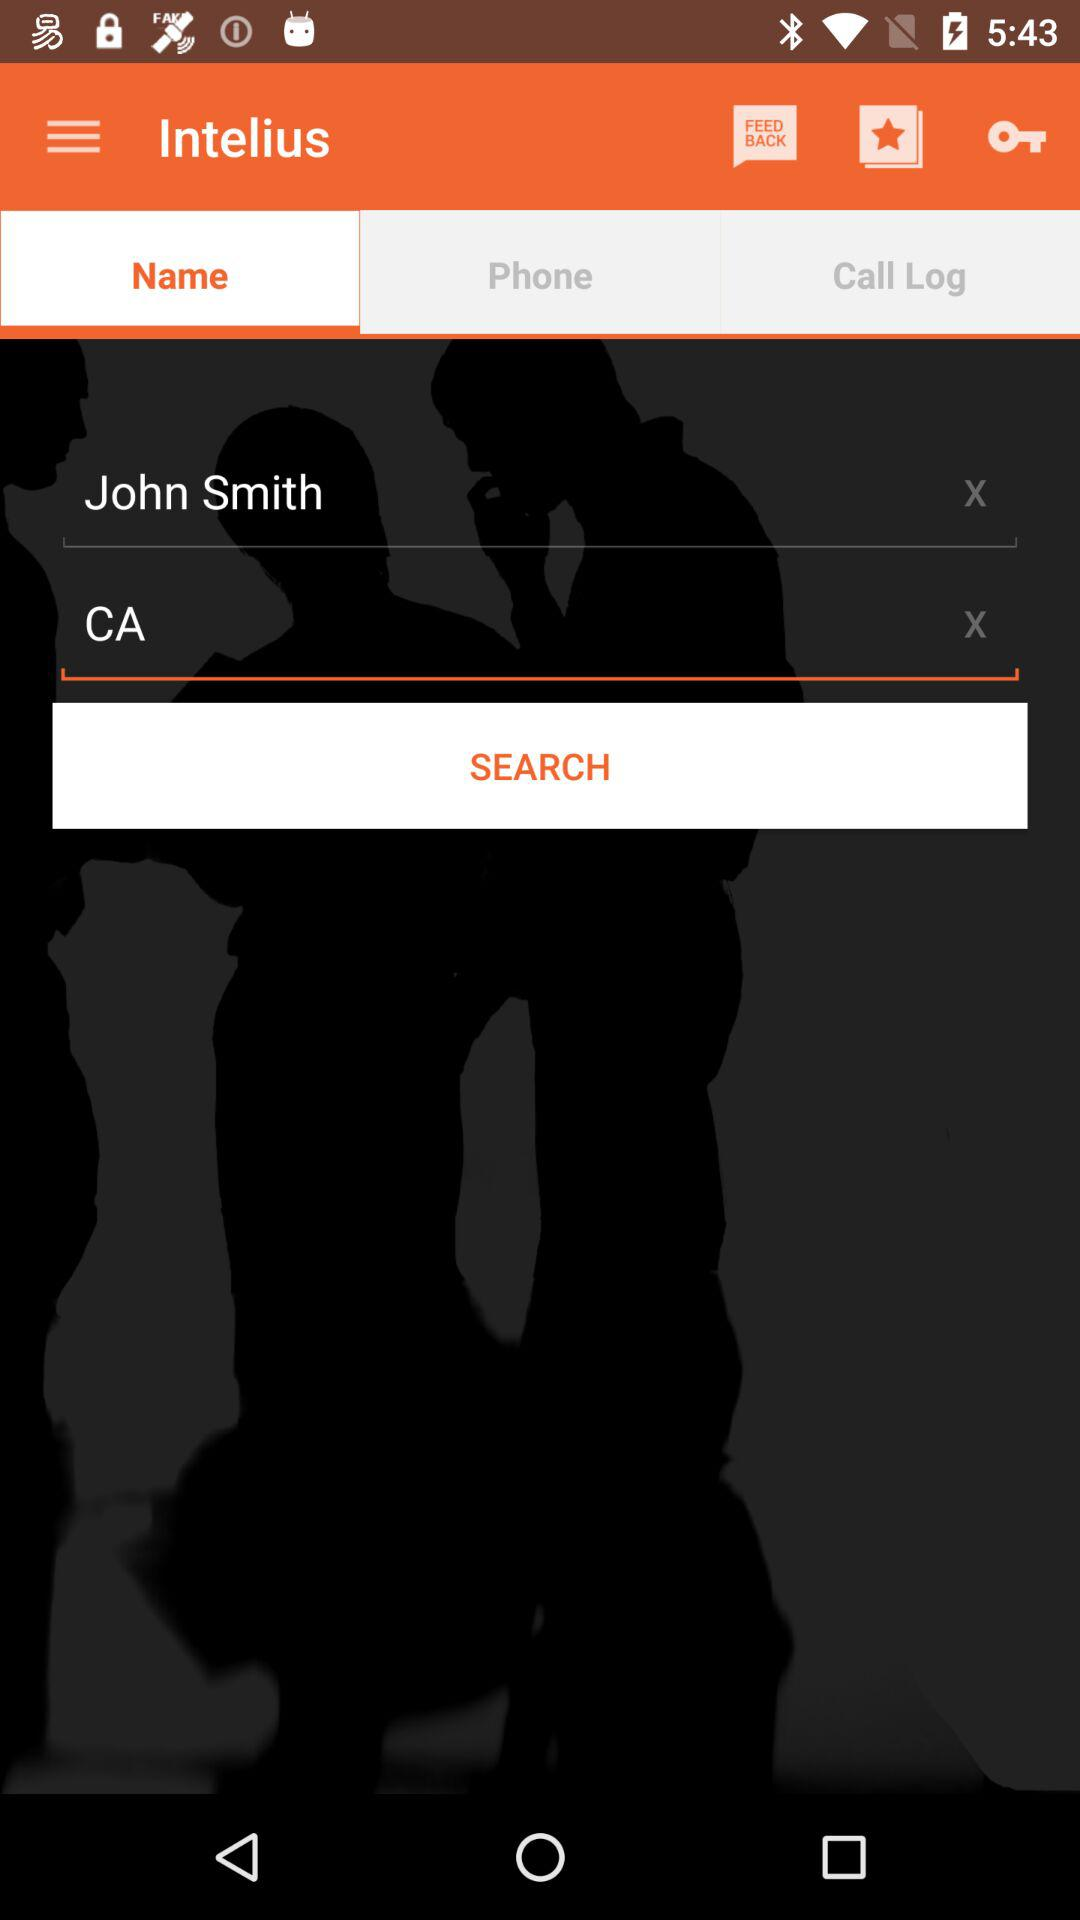Which tab has been selected? The selected tab is "Name". 